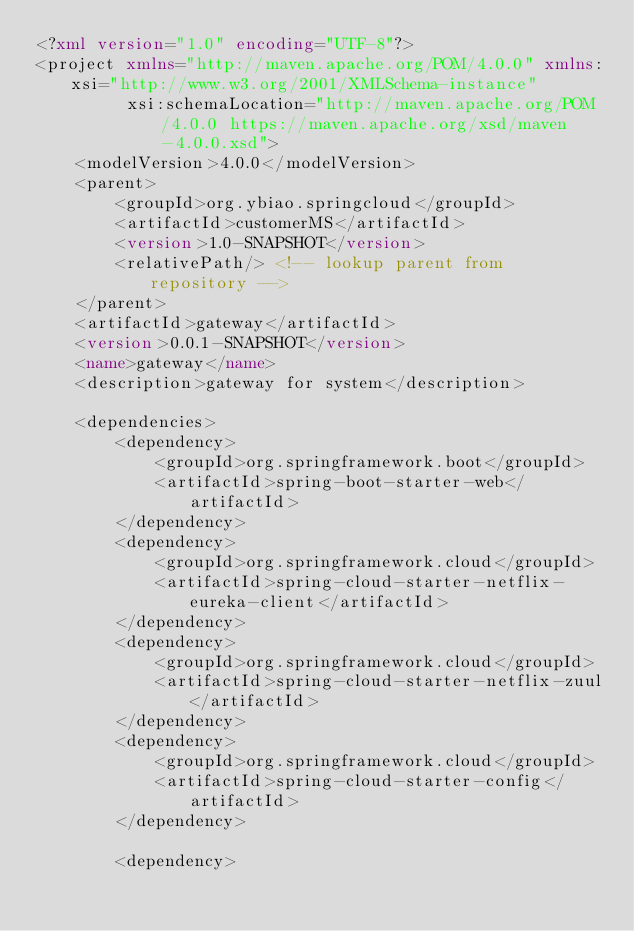<code> <loc_0><loc_0><loc_500><loc_500><_XML_><?xml version="1.0" encoding="UTF-8"?>
<project xmlns="http://maven.apache.org/POM/4.0.0" xmlns:xsi="http://www.w3.org/2001/XMLSchema-instance"
         xsi:schemaLocation="http://maven.apache.org/POM/4.0.0 https://maven.apache.org/xsd/maven-4.0.0.xsd">
    <modelVersion>4.0.0</modelVersion>
    <parent>
        <groupId>org.ybiao.springcloud</groupId>
        <artifactId>customerMS</artifactId>
        <version>1.0-SNAPSHOT</version>
        <relativePath/> <!-- lookup parent from repository -->
    </parent>
    <artifactId>gateway</artifactId>
    <version>0.0.1-SNAPSHOT</version>
    <name>gateway</name>
    <description>gateway for system</description>

    <dependencies>
        <dependency>
            <groupId>org.springframework.boot</groupId>
            <artifactId>spring-boot-starter-web</artifactId>
        </dependency>
        <dependency>
            <groupId>org.springframework.cloud</groupId>
            <artifactId>spring-cloud-starter-netflix-eureka-client</artifactId>
        </dependency>
        <dependency>
            <groupId>org.springframework.cloud</groupId>
            <artifactId>spring-cloud-starter-netflix-zuul</artifactId>
        </dependency>
        <dependency>
            <groupId>org.springframework.cloud</groupId>
            <artifactId>spring-cloud-starter-config</artifactId>
        </dependency>

        <dependency></code> 